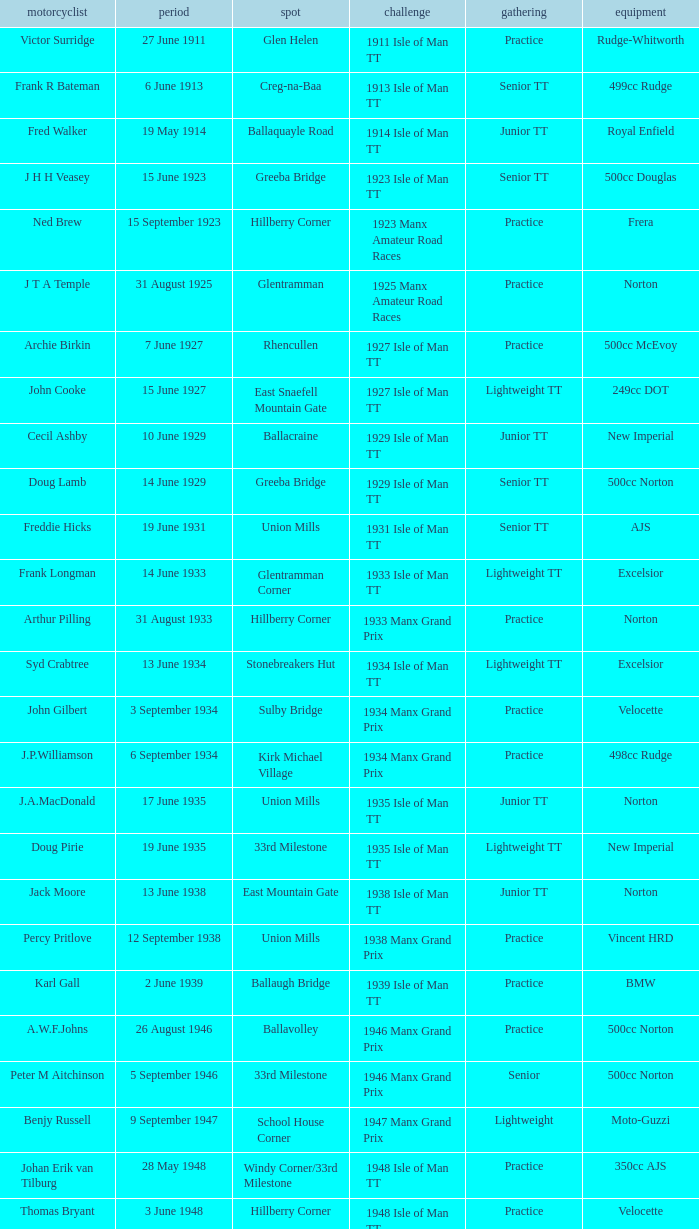On what date does harry l stephen ride a norton machine? 8 June 1953. 